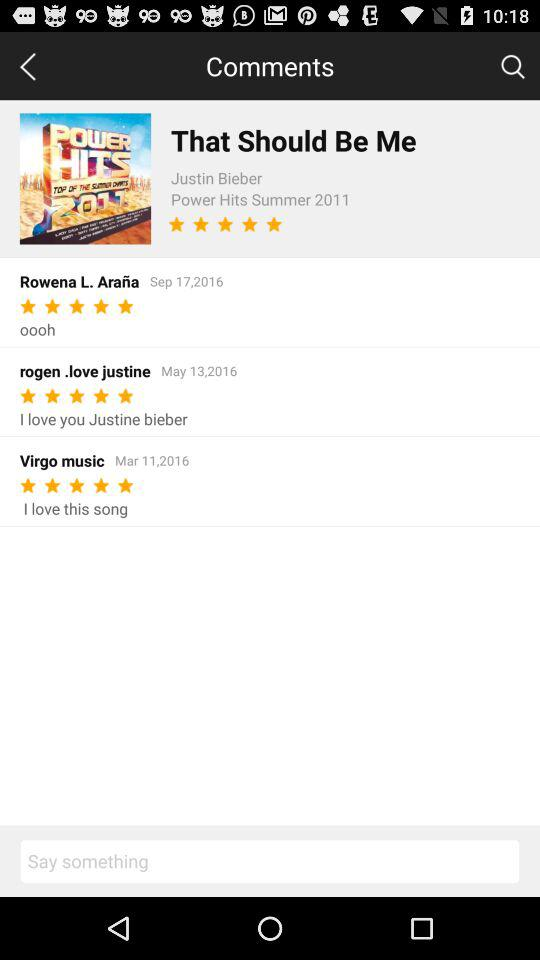What is the rating given by Rowena L. Araña? The rating given by Rowena L. Araña is 5 stars. 